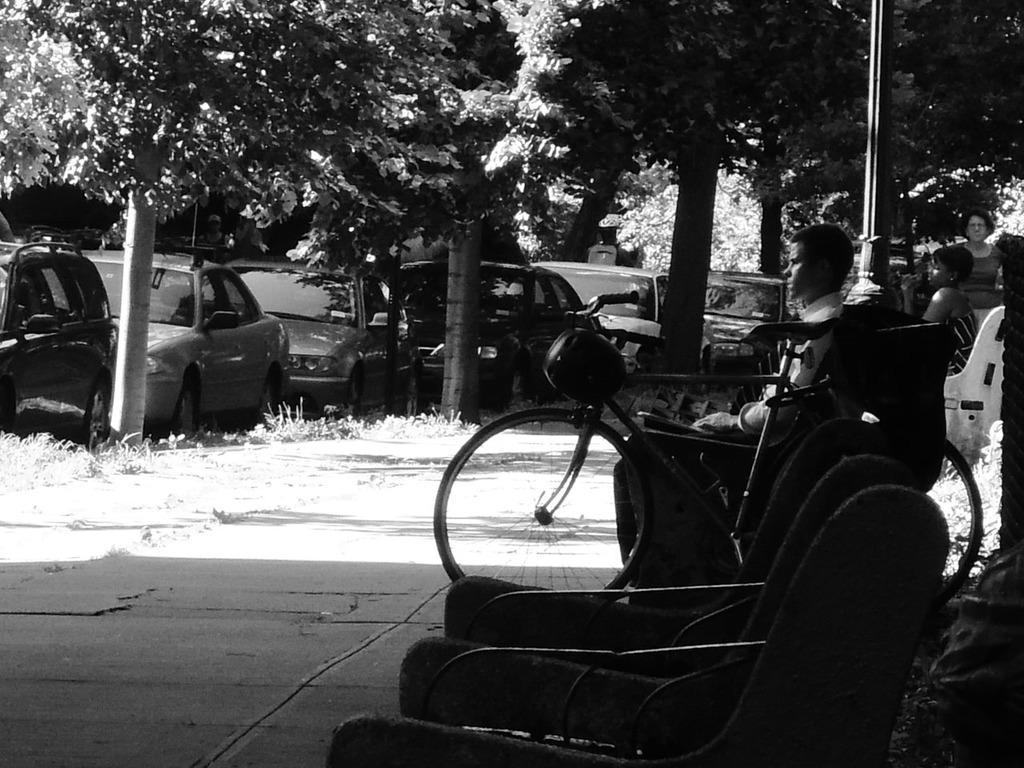Can you describe this image briefly? This is the picture of a black and white image and we can see the sidewalk with some people and benches. There is a bicycle on the sidewalk and there are some vehicles present and we can see the trees. 